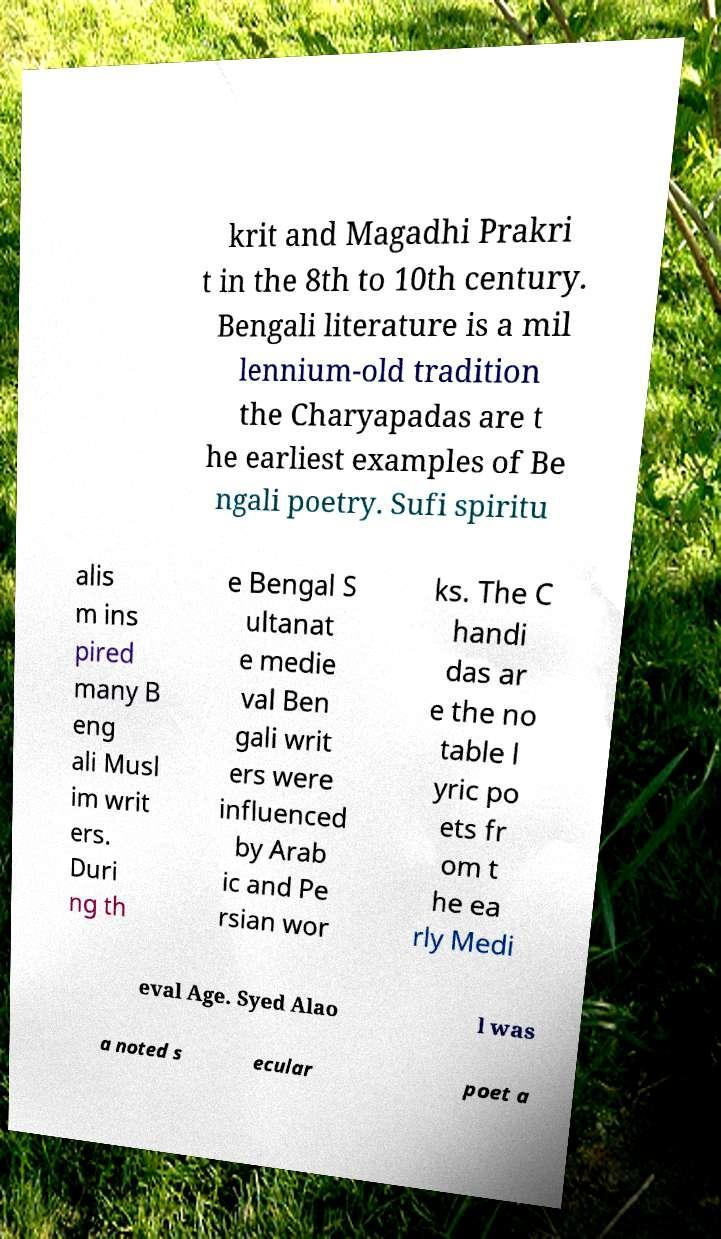There's text embedded in this image that I need extracted. Can you transcribe it verbatim? krit and Magadhi Prakri t in the 8th to 10th century. Bengali literature is a mil lennium-old tradition the Charyapadas are t he earliest examples of Be ngali poetry. Sufi spiritu alis m ins pired many B eng ali Musl im writ ers. Duri ng th e Bengal S ultanat e medie val Ben gali writ ers were influenced by Arab ic and Pe rsian wor ks. The C handi das ar e the no table l yric po ets fr om t he ea rly Medi eval Age. Syed Alao l was a noted s ecular poet a 